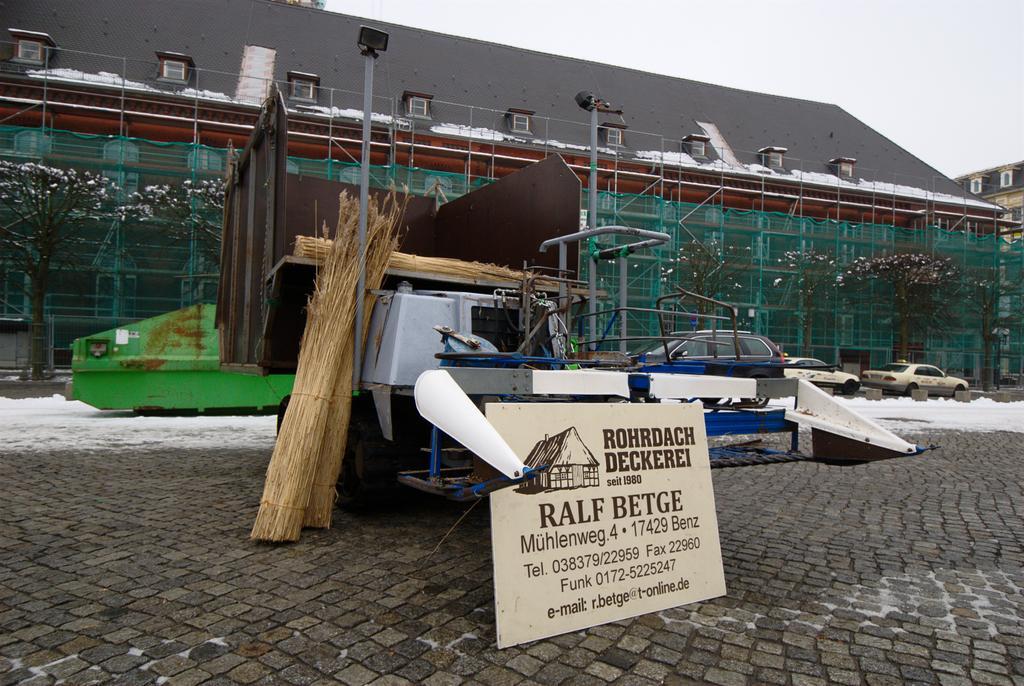How would you summarize this image in a sentence or two? In this image in the front there is a board with some text written on it and there is a machine in the background there is a building and there are poles and their cars and the sky is cloudy 